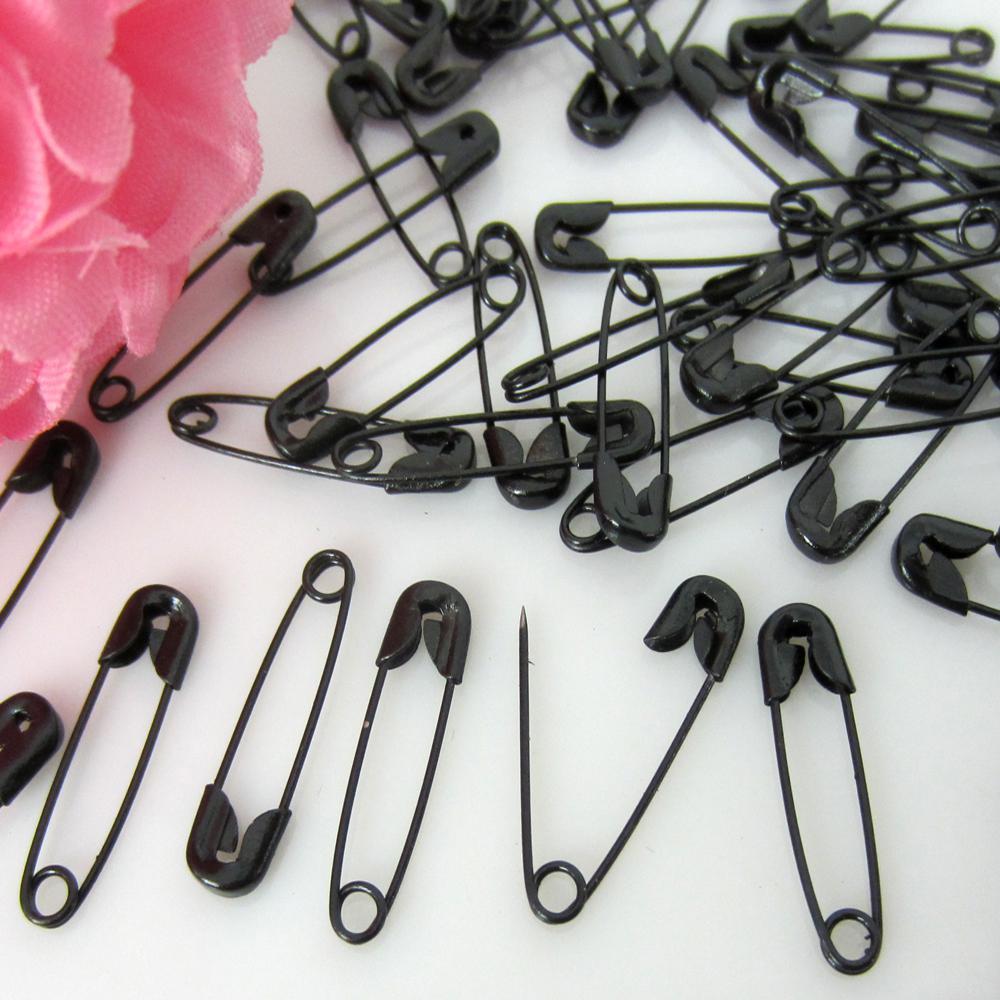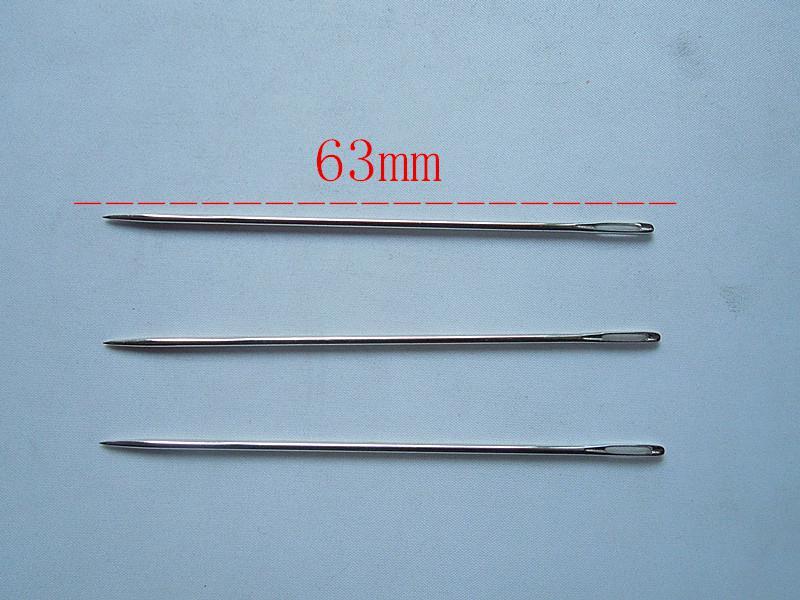The first image is the image on the left, the second image is the image on the right. Assess this claim about the two images: "There are six paperclips total.". Correct or not? Answer yes or no. No. 